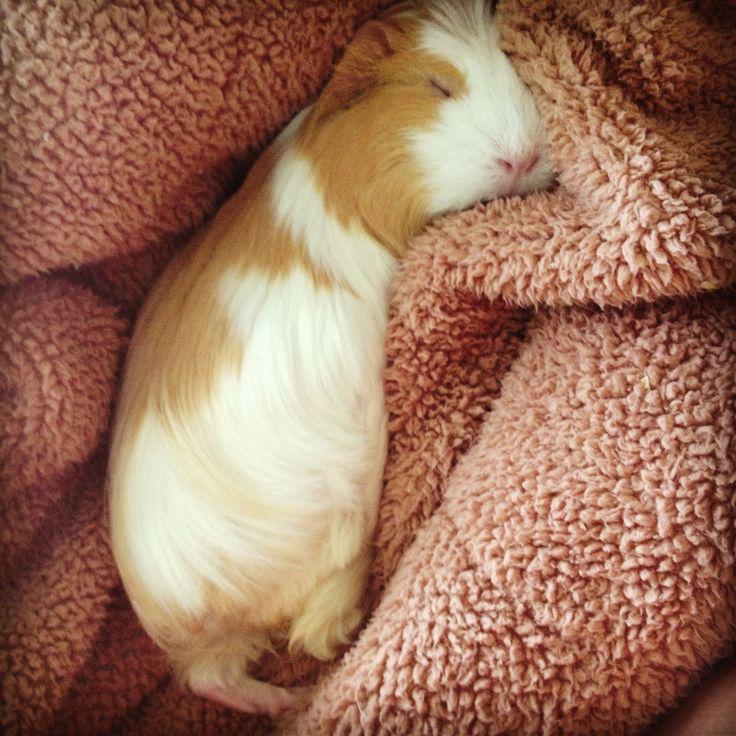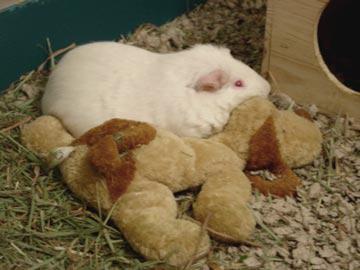The first image is the image on the left, the second image is the image on the right. Analyze the images presented: Is the assertion "There are at least three rodents in the image on the left." valid? Answer yes or no. No. The first image is the image on the left, the second image is the image on the right. Evaluate the accuracy of this statement regarding the images: "One image shows a hamster laying with an animal that is not a hamster.". Is it true? Answer yes or no. Yes. 